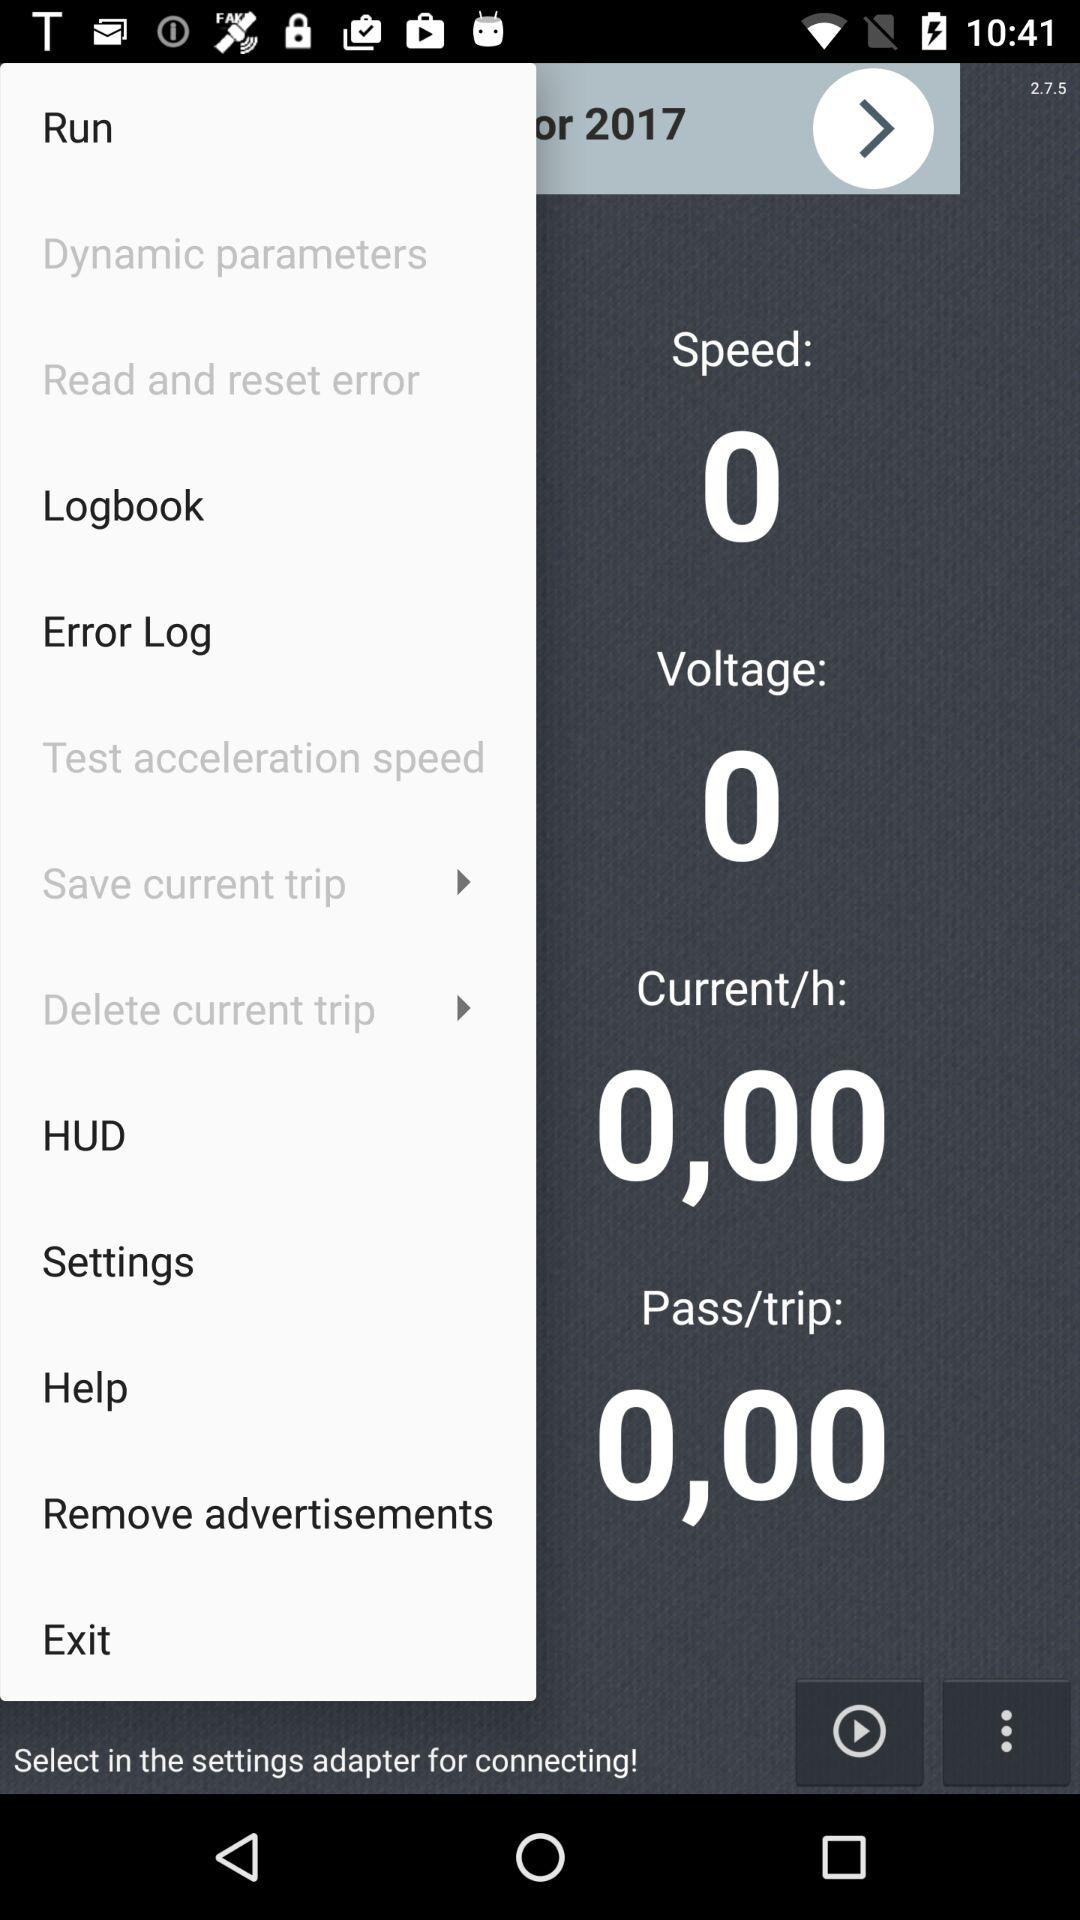What is the "Current/h"? The "Current/h" is 0,00. 